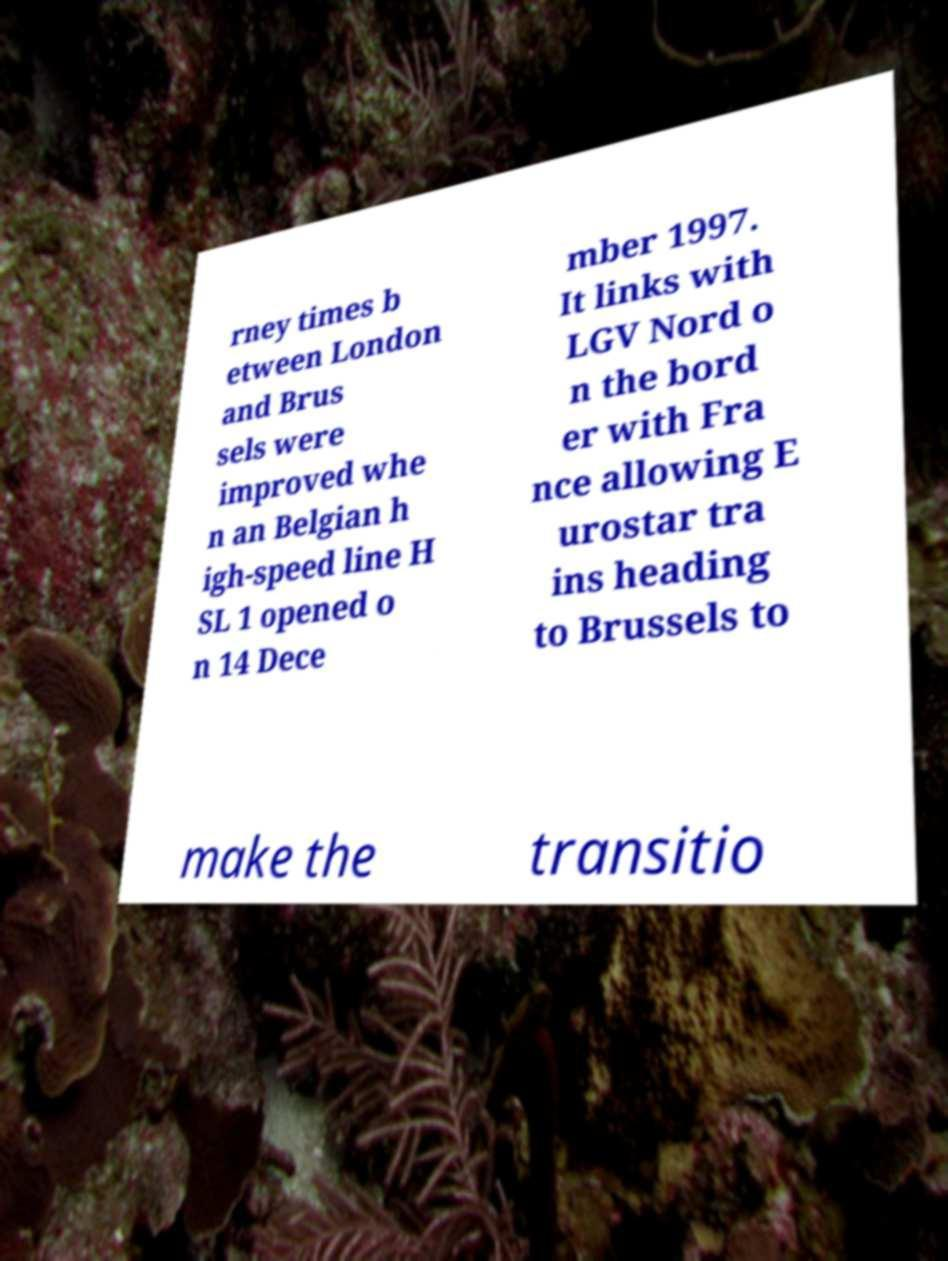For documentation purposes, I need the text within this image transcribed. Could you provide that? rney times b etween London and Brus sels were improved whe n an Belgian h igh-speed line H SL 1 opened o n 14 Dece mber 1997. It links with LGV Nord o n the bord er with Fra nce allowing E urostar tra ins heading to Brussels to make the transitio 